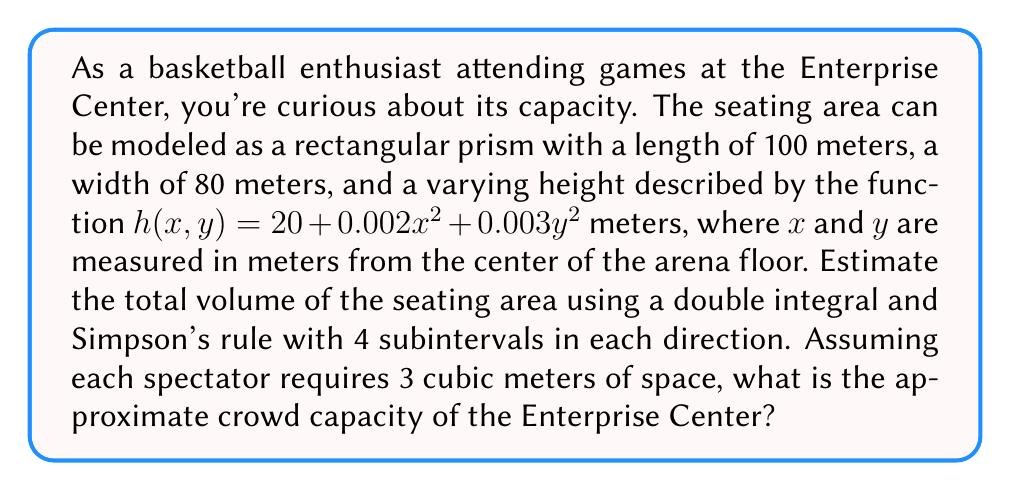Help me with this question. To solve this problem, we'll follow these steps:

1) Set up the double integral for the volume:
   $$V = \int_{-50}^{50} \int_{-40}^{40} (20 + 0.002x^2 + 0.003y^2) \, dy \, dx$$

2) Apply Simpson's rule in both directions with 4 subintervals:
   $$\begin{align*}
   V &\approx \frac{hk}{9} [f(x_0,y_0) + 4f(x_0,y_1) + 2f(x_0,y_2) + 4f(x_0,y_3) + f(x_0,y_4) \\
   &+ 4(f(x_1,y_0) + 4f(x_1,y_1) + 2f(x_1,y_2) + 4f(x_1,y_3) + f(x_1,y_4)) \\
   &+ 2(f(x_2,y_0) + 4f(x_2,y_1) + 2f(x_2,y_2) + 4f(x_2,y_3) + f(x_2,y_4)) \\
   &+ 4(f(x_3,y_0) + 4f(x_3,y_1) + 2f(x_3,y_2) + 4f(x_3,y_3) + f(x_3,y_4)) \\
   &+ f(x_4,y_0) + 4f(x_4,y_1) + 2f(x_4,y_2) + 4f(x_4,y_3) + f(x_4,y_4)]
   \end{align*}$$

   Where $h = 25$ and $k = 20$ (step sizes in $x$ and $y$ directions)

3) Calculate function values at grid points:
   $x_0 = -50, x_1 = -25, x_2 = 0, x_3 = 25, x_4 = 50$
   $y_0 = -40, y_1 = -20, y_2 = 0, y_3 = 20, y_4 = 40$

4) Substitute these values into Simpson's rule formula and calculate the volume.

5) Divide the volume by 3 cubic meters per person to get the crowd capacity.

Performing these calculations:

$$\begin{align*}
V &\approx \frac{25 \cdot 20}{9} [20 + 24 + 26 + 24 + 20 \\
&+ 4(22.5 + 26.5 + 28.5 + 26.5 + 22.5) \\
&+ 2(25 + 29 + 31 + 29 + 25) \\
&+ 4(27.5 + 31.5 + 33.5 + 31.5 + 27.5) \\
&+ 30 + 34 + 36 + 34 + 30] \\
&= \frac{500}{9} \cdot 1130 \\
&= 62,777.78 \text{ cubic meters}
\end{align*}$$

Crowd capacity $= 62,777.78 / 3 \approx 20,926$ people
Answer: The approximate crowd capacity of the Enterprise Center is 20,926 people. 